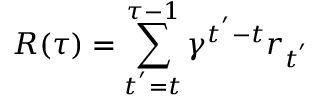<formula> <loc_0><loc_0><loc_500><loc_500>R ( \tau ) = \sum _ { t ^ { ^ { \prime } } = t } ^ { \tau - 1 } \gamma ^ { t ^ { ^ { \prime } } - t } r _ { t ^ { ^ { \prime } } }</formula> 